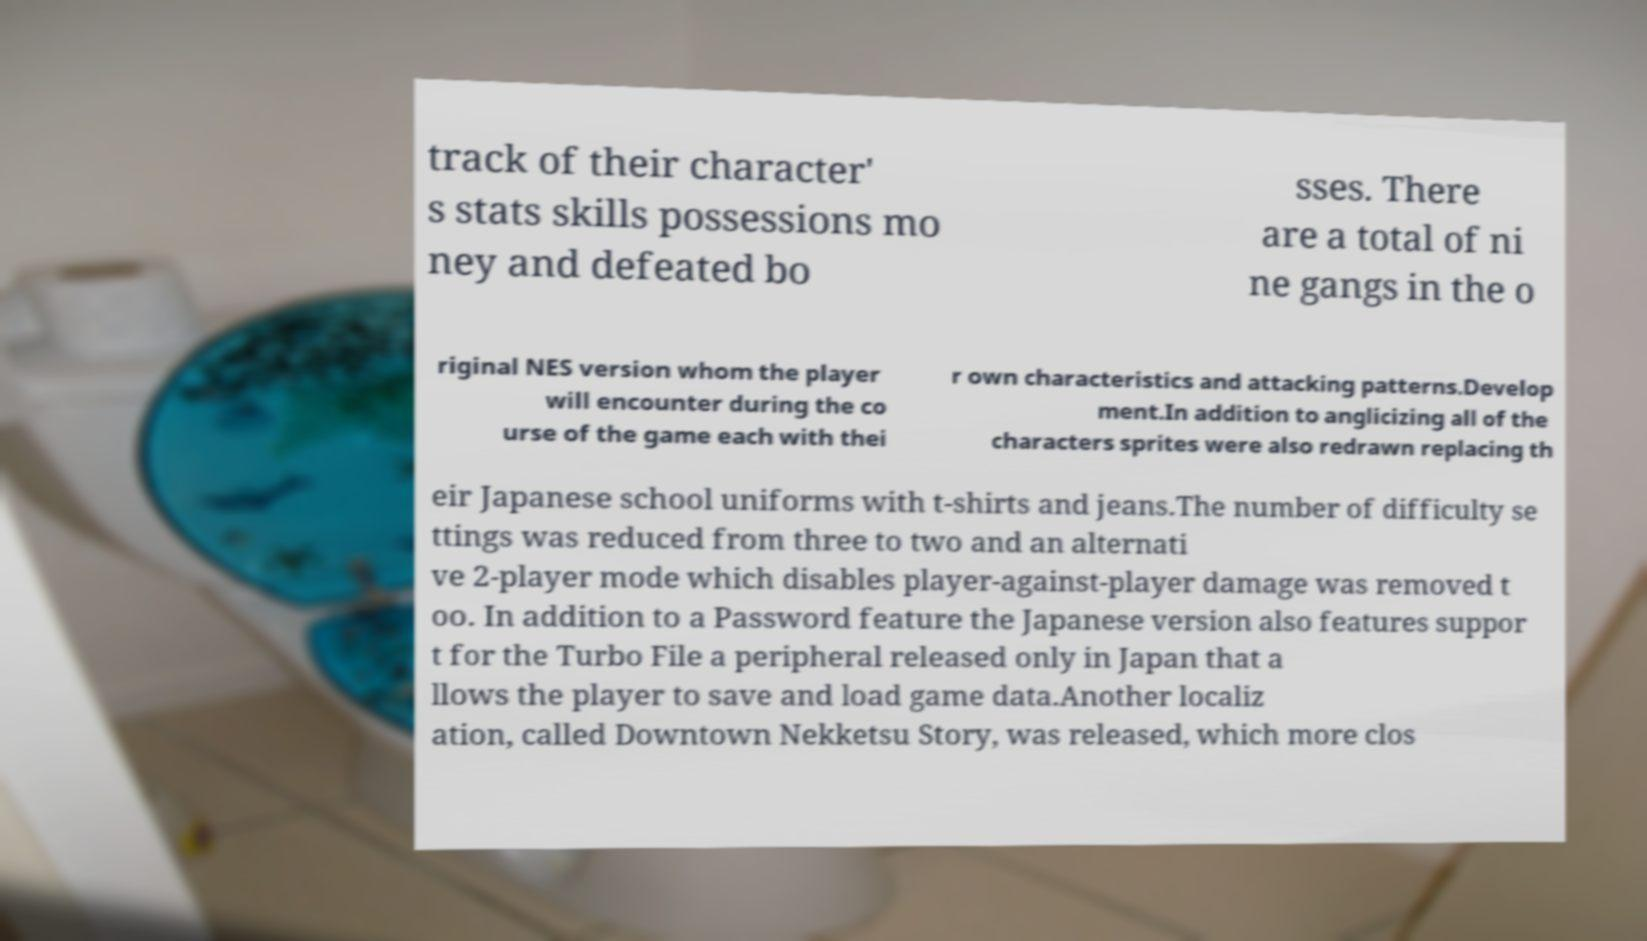There's text embedded in this image that I need extracted. Can you transcribe it verbatim? track of their character' s stats skills possessions mo ney and defeated bo sses. There are a total of ni ne gangs in the o riginal NES version whom the player will encounter during the co urse of the game each with thei r own characteristics and attacking patterns.Develop ment.In addition to anglicizing all of the characters sprites were also redrawn replacing th eir Japanese school uniforms with t-shirts and jeans.The number of difficulty se ttings was reduced from three to two and an alternati ve 2-player mode which disables player-against-player damage was removed t oo. In addition to a Password feature the Japanese version also features suppor t for the Turbo File a peripheral released only in Japan that a llows the player to save and load game data.Another localiz ation, called Downtown Nekketsu Story, was released, which more clos 